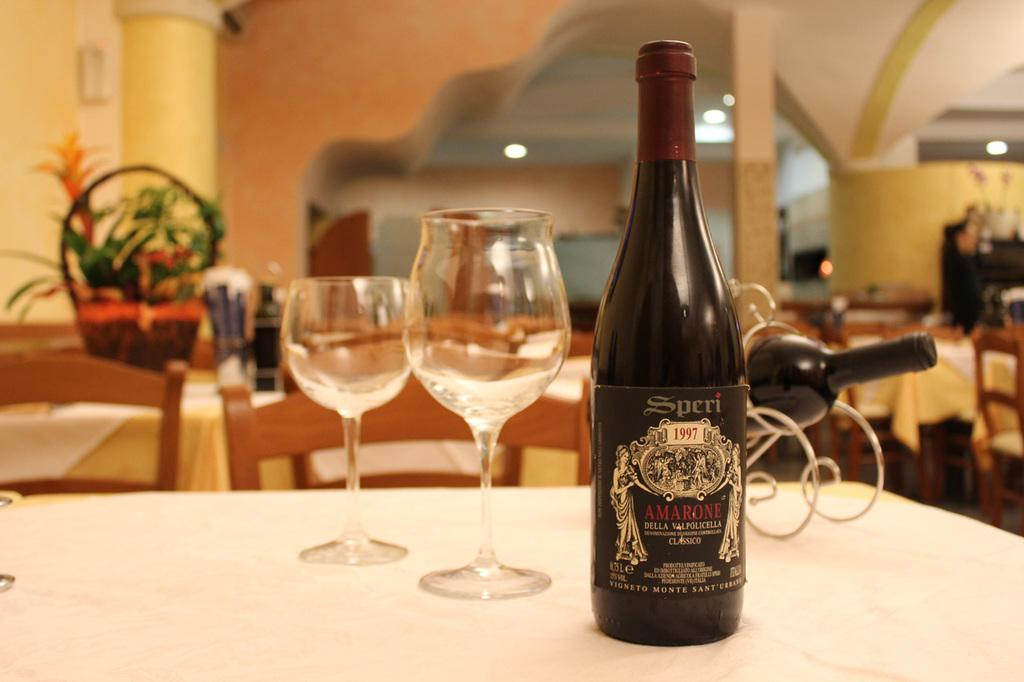What type of container is visible in the image? There is a glass bottle in the image. What type of glasses are on the table in the image? There are wine glasses in the image. What other objects can be seen on the table in the image? There are other objects on the table in the image, but their specific details are not mentioned in the provided facts. What type of pain is the governor experiencing while wearing a veil in the image? There is no governor, pain, or veil present in the image. 